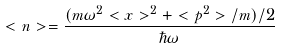<formula> <loc_0><loc_0><loc_500><loc_500>< n > = \frac { ( m \omega ^ { 2 } < x > ^ { 2 } + < p ^ { 2 } > / m ) / 2 } { \hbar { \omega } }</formula> 